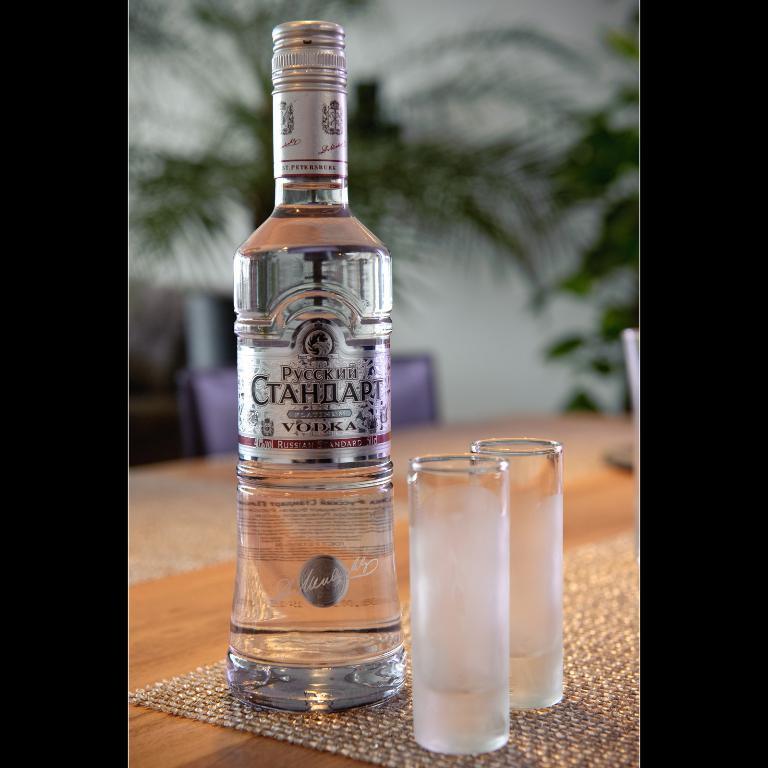What kind of spirit is about to be served?
Provide a succinct answer. Vodka. 